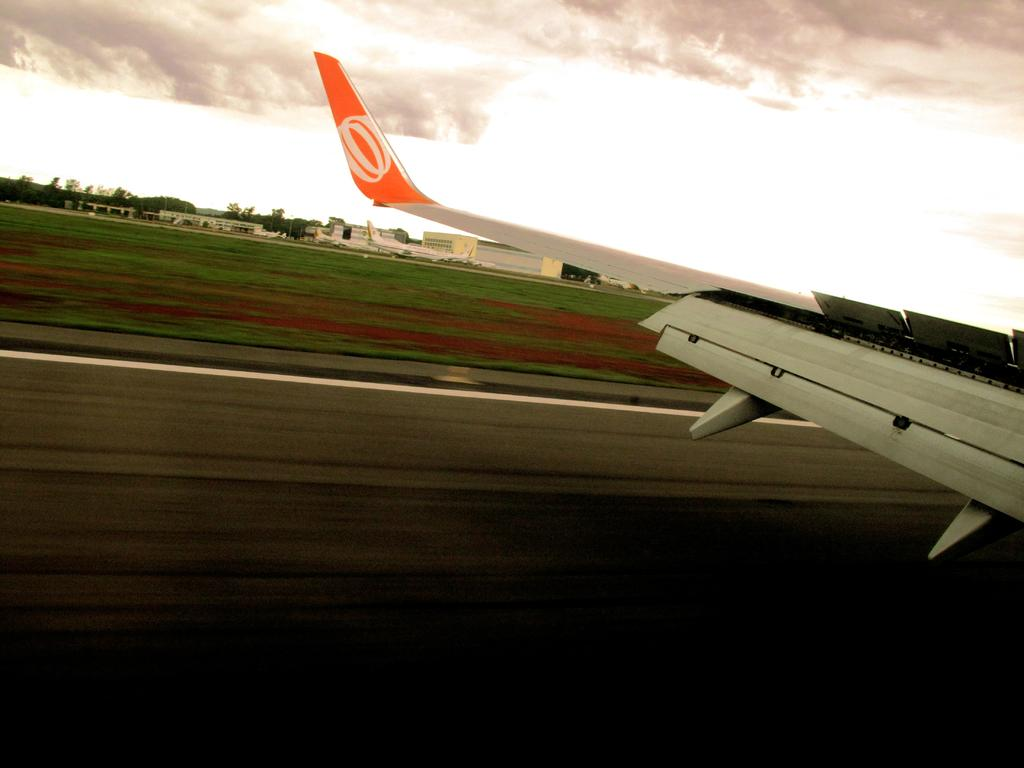What part of an airplane can be seen in the image? There is a wing of an airplane in the image. What is featured on the wing of the airplane? A logo is printed on the wing. What type of natural environment is visible in the background of the image? There is grass, trees, and clouds visible in the background of the image. What type of man-made structures can be seen in the background of the image? There are buildings in the background of the image. What type of straw is being used to stir the clouds in the image? There is no straw present in the image, and the clouds are not being stirred. 